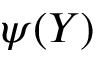Convert formula to latex. <formula><loc_0><loc_0><loc_500><loc_500>\psi ( Y )</formula> 